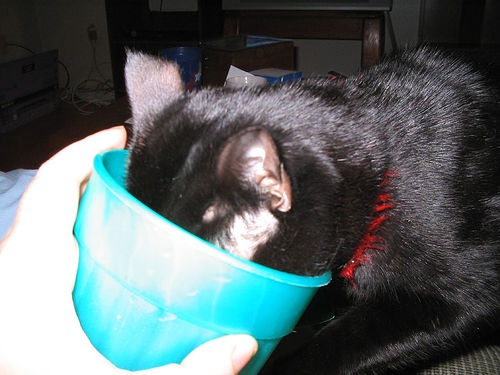Describe the objects in this image and their specific colors. I can see cat in black, gray, darkgray, and lightgray tones, bowl in black, white, and cyan tones, and people in black, white, lightblue, maroon, and lightpink tones in this image. 